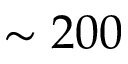<formula> <loc_0><loc_0><loc_500><loc_500>\sim 2 0 0</formula> 